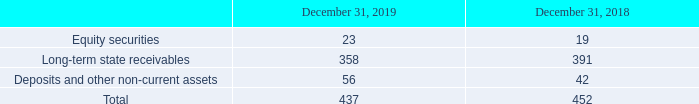Long-term state receivables include receivables related to funding and receivables related to tax refund. Funding are mainly public grants to be received from governmental agencies in Italy and France as part of longterm research and development, industrialization and capital investment projects. Long-term receivables related to tax refund correspond to tax benefits claimed by the Company in certain of its local tax jurisdictions, for which collection is expected beyond one year.
In 2019 and 2018, the Company entered into a factoring transaction to accelerate the realization in cash of some non-current assets. As at December 31, 2019, $131 million of the non-current assets were sold without recourse, compared to $122 million as at December 31, 2018, with a financial cost of less than $1 million for both periods.
Other non-current assets consisted of the following:
How many non-current assets were sold without recourse as of December 31, 2019? $131 million. How many non-current assets were sold without recourse as of December 31, 2018? $122 million. What does Long-term state receivables include? Long-term state receivables include receivables related to funding and receivables related to tax refund. What is the average Equity securities?
Answer scale should be: million. (23+19) / 2
Answer: 21. What is the average Long-term state receivables?
Answer scale should be: million. (358+391) / 2
Answer: 374.5. What is the average Deposits and other non-current assets?
Answer scale should be: million. (56+42) / 2
Answer: 49. 